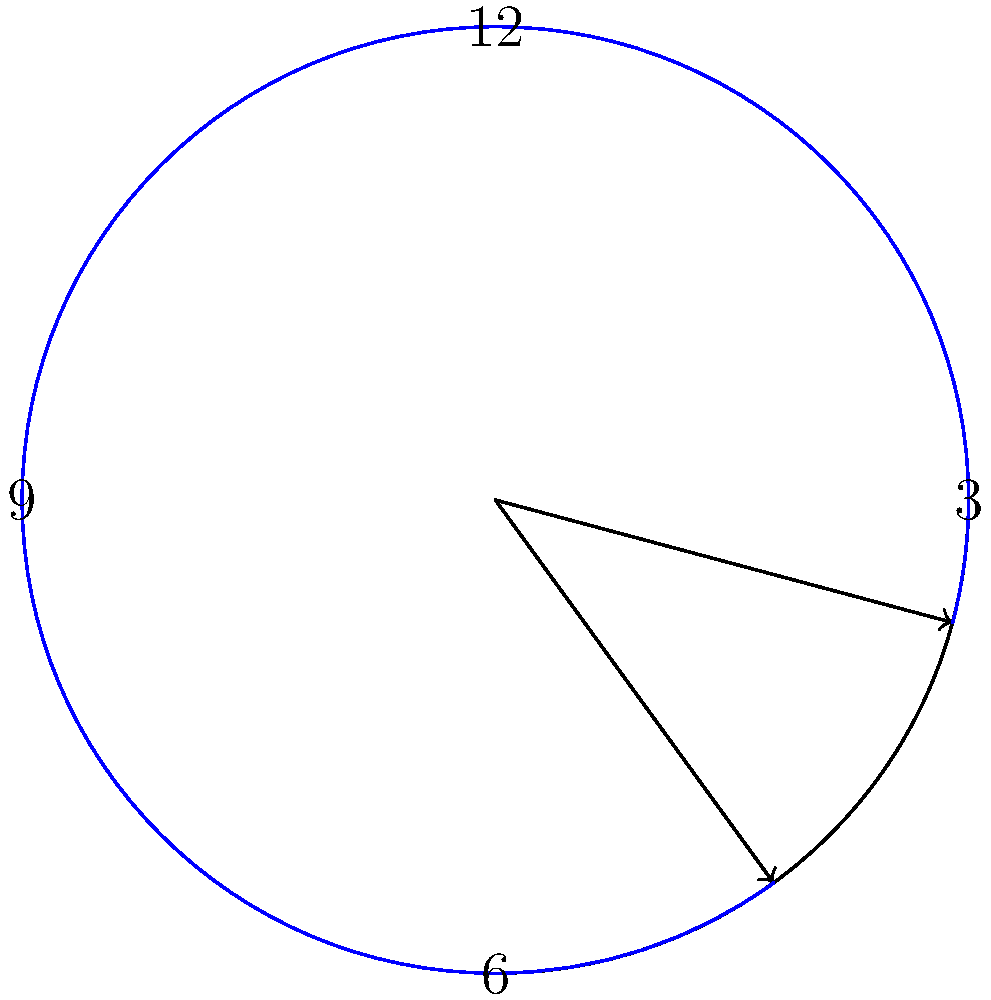During a crucial legislative assembly session, the clock shows 2:30. What is the angle formed between the hour and minute hands of the clock at this time? To find the angle between the hour and minute hands at 2:30, we can follow these steps:

1) First, calculate the angle moved by the hour hand:
   - In 12 hours, the hour hand rotates 360°
   - In 1 hour, it rotates 360° ÷ 12 = 30°
   - In 2.5 hours (2:30), it rotates: 2.5 × 30° = 75°

2) Then, calculate the angle moved by the minute hand:
   - In 60 minutes, the minute hand rotates 360°
   - In 30 minutes, it rotates: (30 ÷ 60) × 360° = 180°

3) The angle between the hands is the absolute difference:
   $|180° - 75°| = 105°$

4) However, we need to consider the smaller angle. If the result is greater than 180°, we subtract it from 360°:
   105° is less than 180°, so this is our final answer.

Therefore, the angle between the hour and minute hands at 2:30 is 105°.
Answer: 105° 